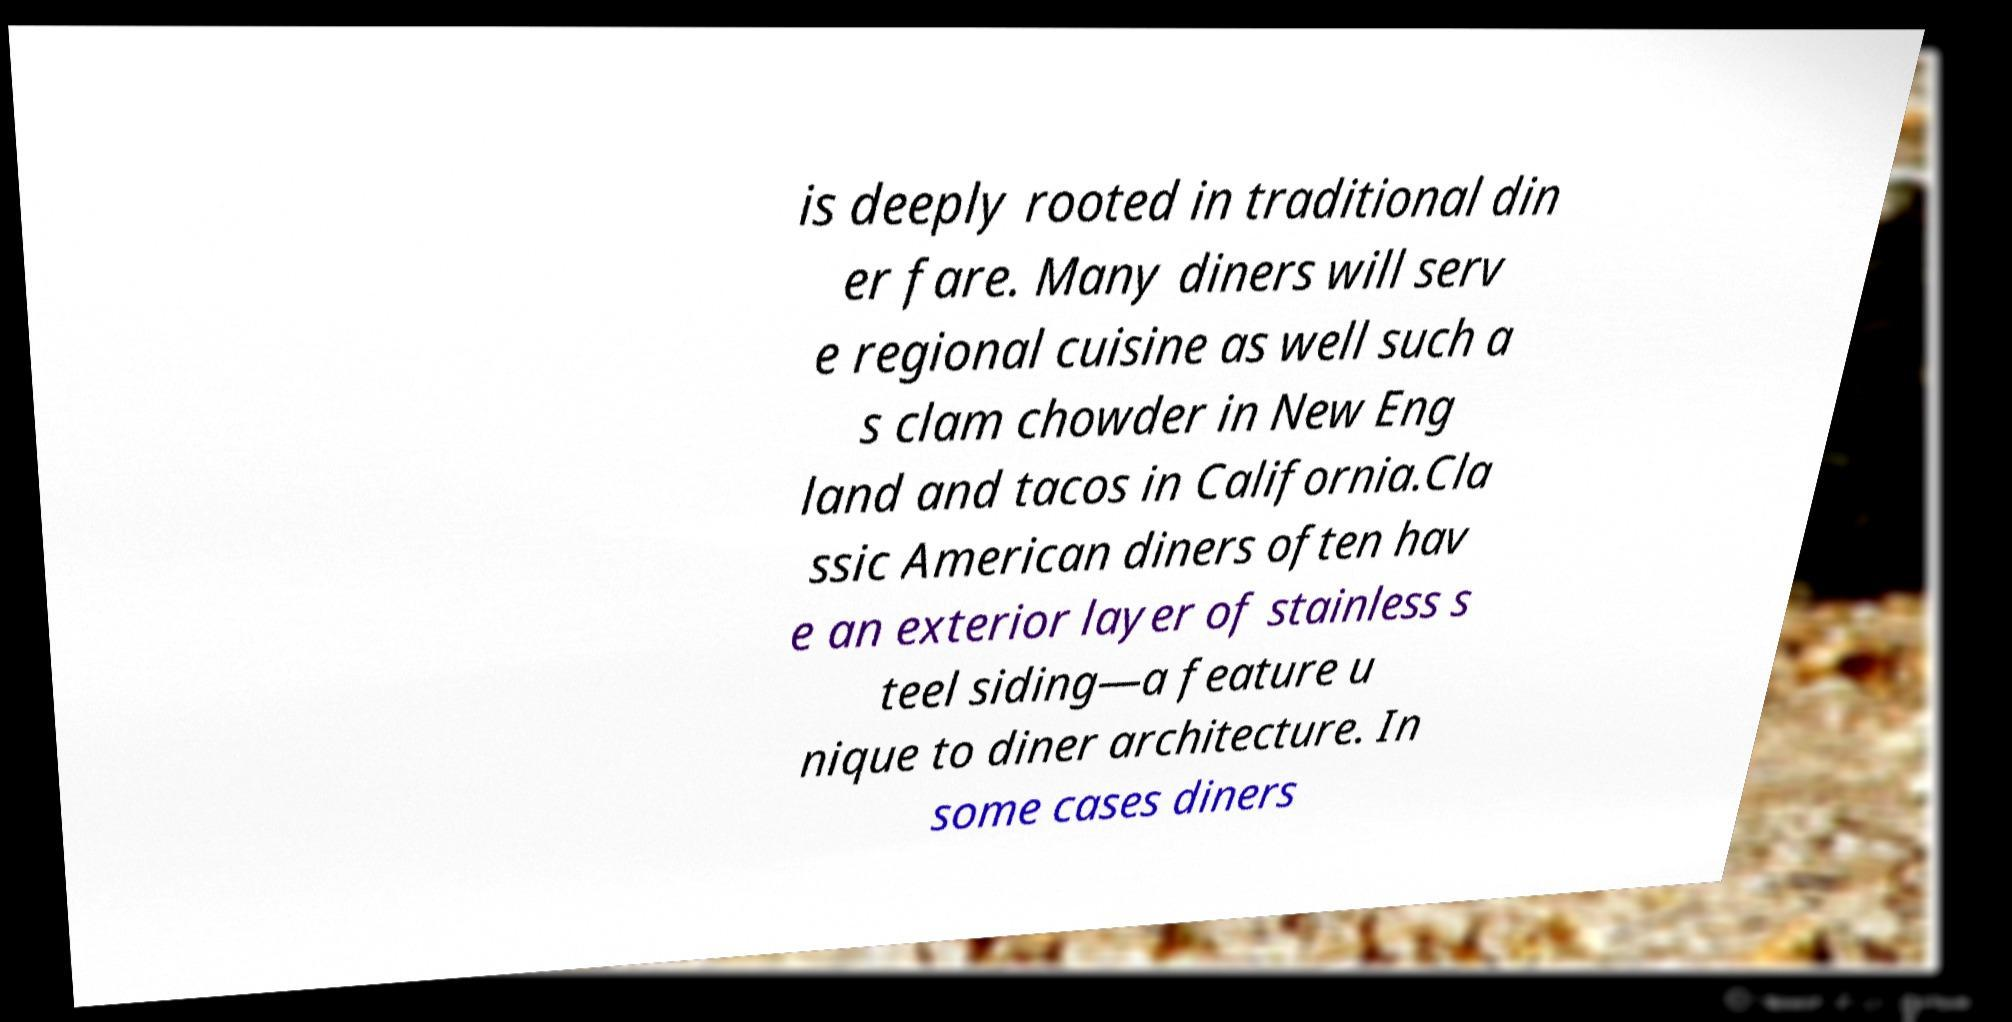Please read and relay the text visible in this image. What does it say? is deeply rooted in traditional din er fare. Many diners will serv e regional cuisine as well such a s clam chowder in New Eng land and tacos in California.Cla ssic American diners often hav e an exterior layer of stainless s teel siding—a feature u nique to diner architecture. In some cases diners 